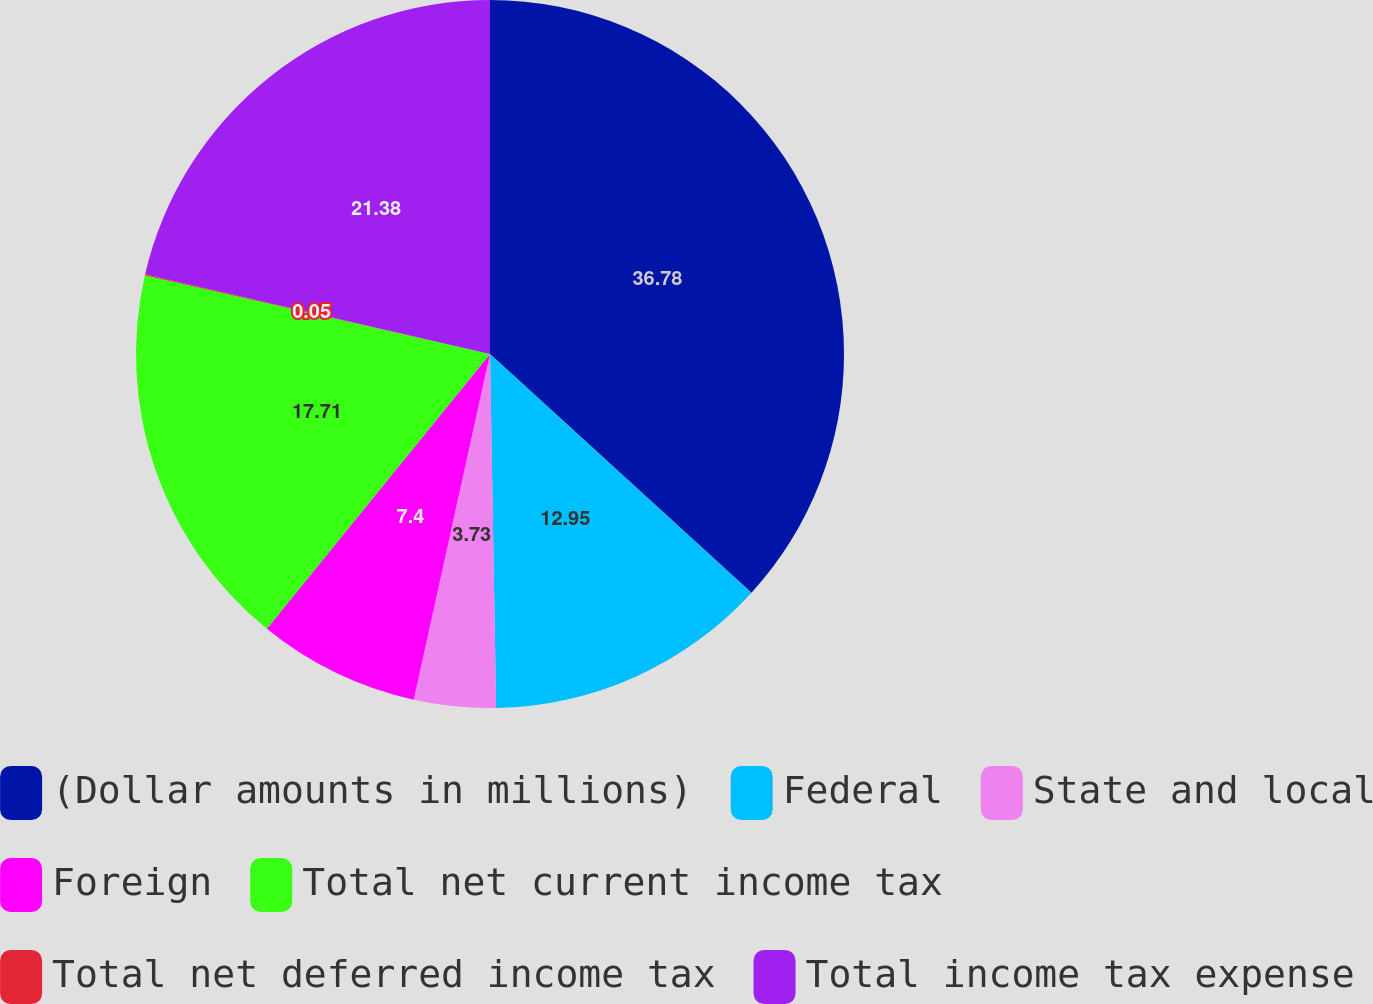Convert chart. <chart><loc_0><loc_0><loc_500><loc_500><pie_chart><fcel>(Dollar amounts in millions)<fcel>Federal<fcel>State and local<fcel>Foreign<fcel>Total net current income tax<fcel>Total net deferred income tax<fcel>Total income tax expense<nl><fcel>36.77%<fcel>12.95%<fcel>3.73%<fcel>7.4%<fcel>17.71%<fcel>0.05%<fcel>21.38%<nl></chart> 